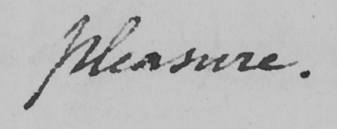What is written in this line of handwriting? pleasure . 